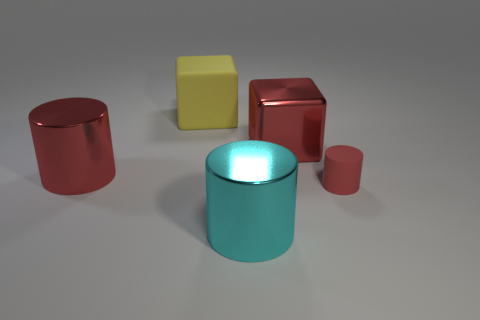Subtract all large metal cylinders. How many cylinders are left? 1 Add 4 small blue matte cylinders. How many objects exist? 9 Subtract all cyan cylinders. How many cylinders are left? 2 Subtract all blocks. How many objects are left? 3 Subtract 2 cylinders. How many cylinders are left? 1 Subtract all yellow balls. How many red cylinders are left? 2 Add 4 large cyan cylinders. How many large cyan cylinders are left? 5 Add 3 large cyan metal objects. How many large cyan metal objects exist? 4 Subtract 0 gray cylinders. How many objects are left? 5 Subtract all purple cubes. Subtract all red cylinders. How many cubes are left? 2 